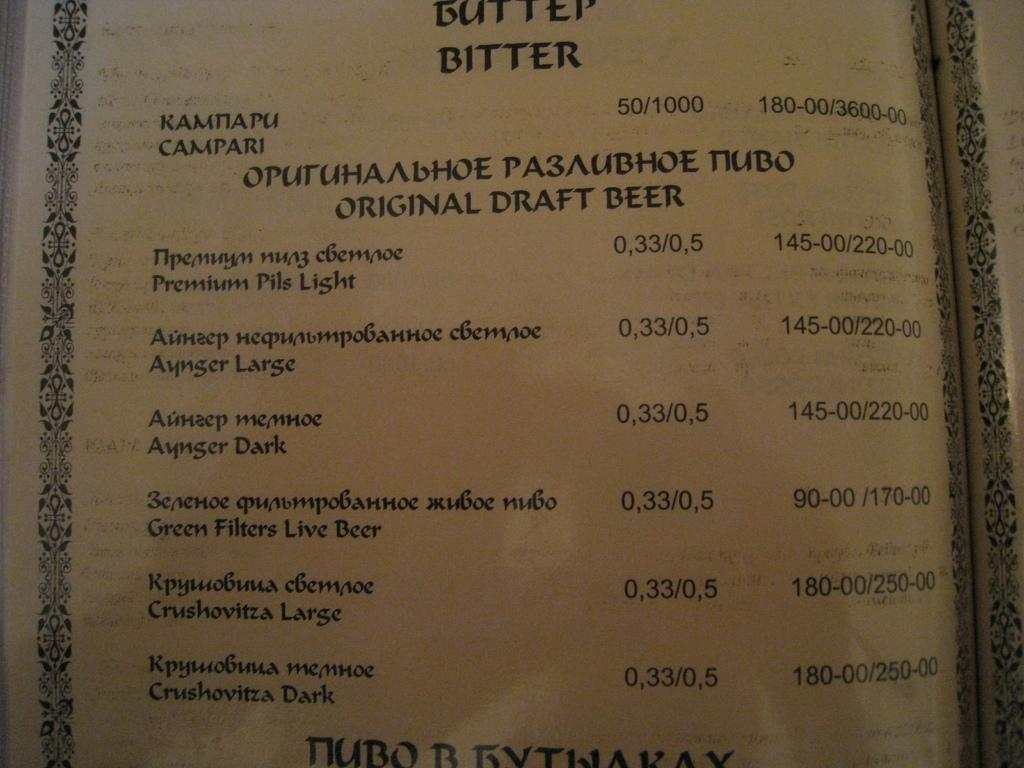<image>
Provide a brief description of the given image. A Menu of Buffet Bitter including prices of food. 